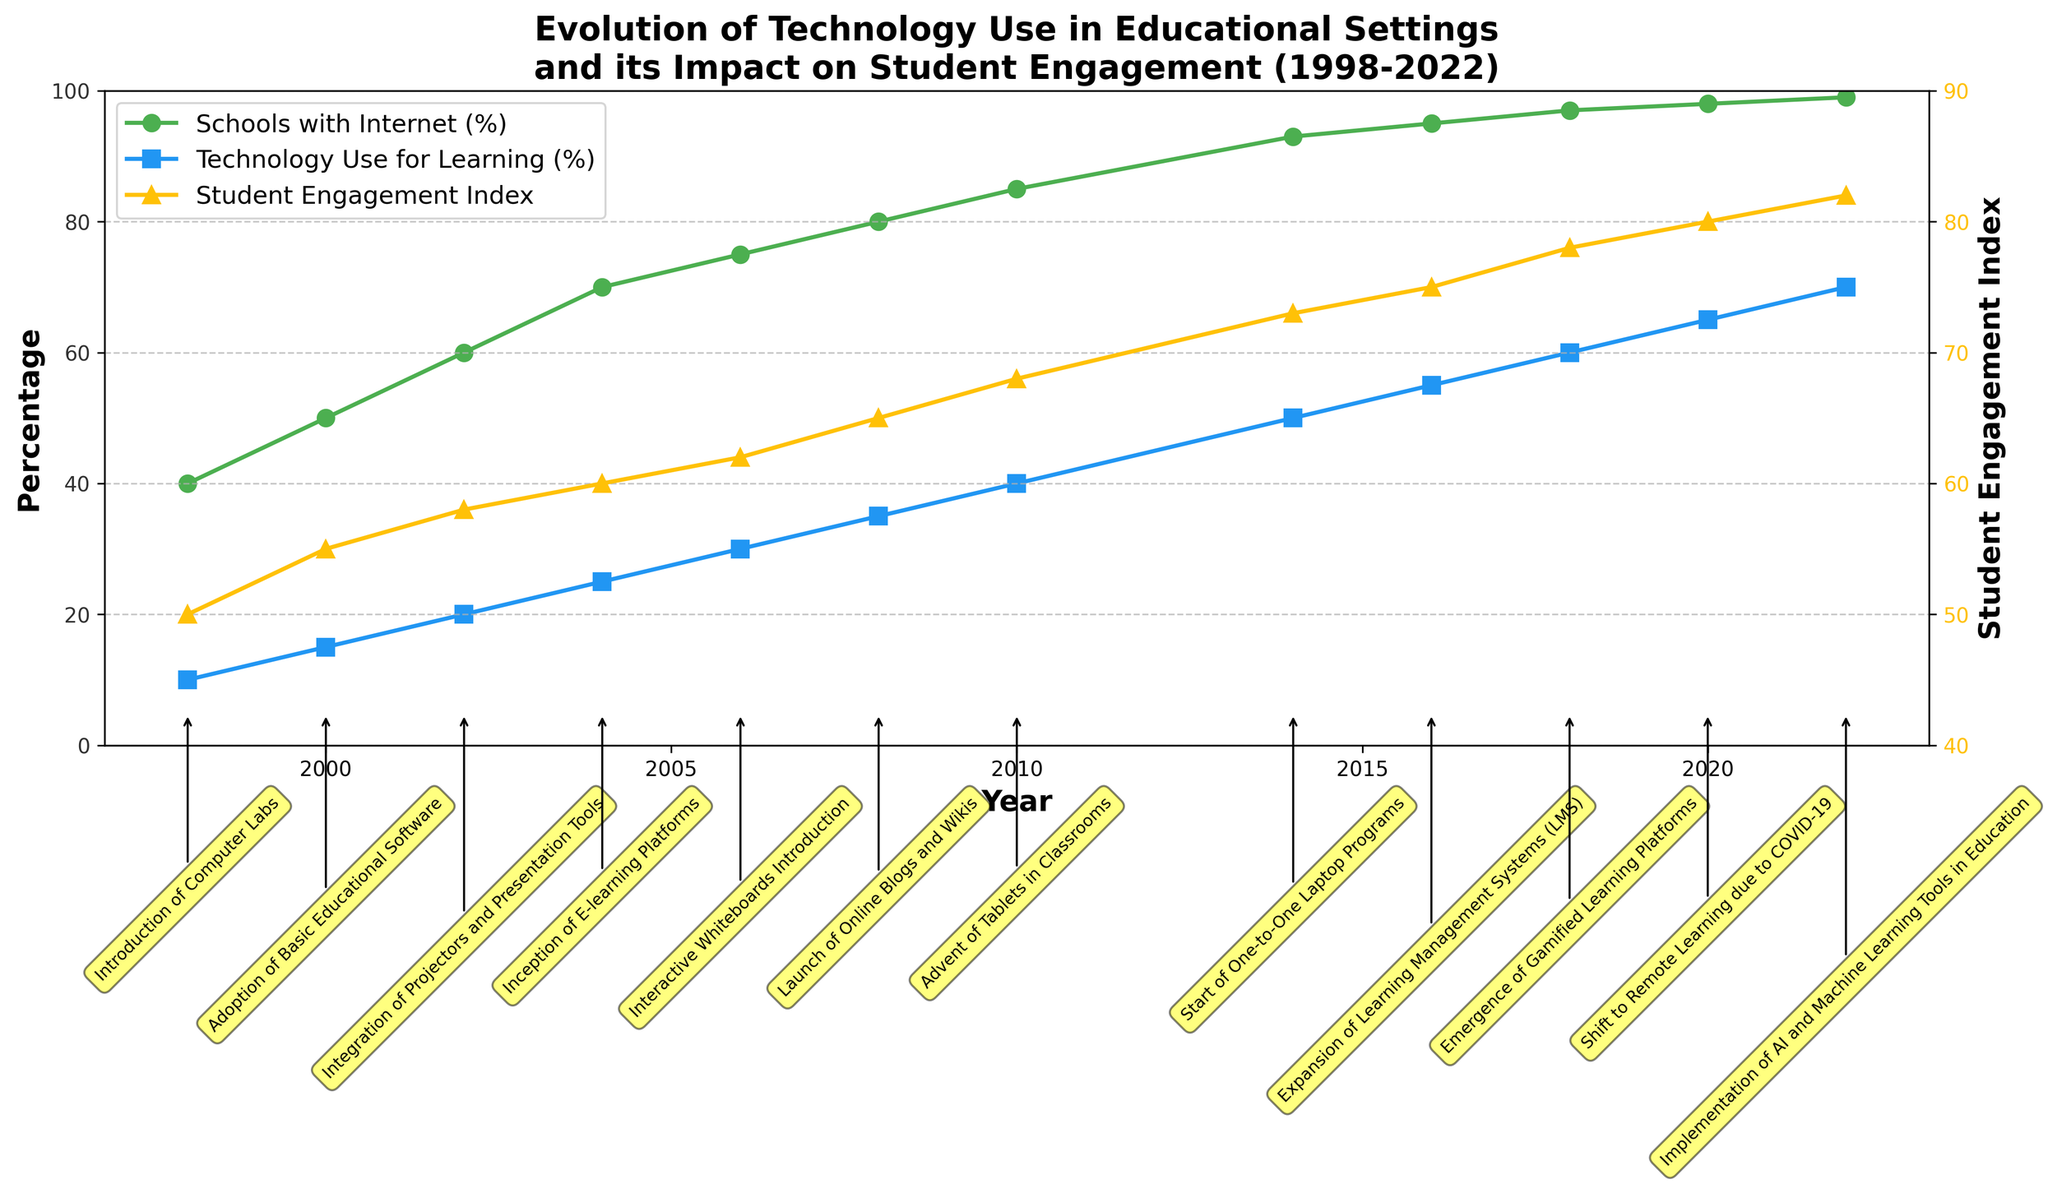What is the title of the plot? The title of the plot is located at the top and provides a summary of what the figure represents.
Answer: Evolution of Technology Use in Educational Settings and its Impact on Student Engagement (1998-2022) What two metrics are plotted on the primary y-axis? The primary y-axis on the left side of the plot typically has labels and descriptions for the metrics it represents.
Answer: Percentage Of Schools With Internet and Technology Use For Learning How many data points are there for the Student Engagement Index? To find the number of data points for the Student Engagement Index, count the number of points or markers plotted for this metric.
Answer: 12 In which year was the "Advent of Tablets in Classrooms"? Look for the annotation text near each data point. The year for the "Advent of Tablets in Classrooms" can be identified next to its corresponding annotation.
Answer: 2010 By how much did the Student Engagement Index increase from 2006 to 2020? Identify the values of the Student Engagement Index in the years 2006 and 2020, then subtract the 2006 value from the 2020 value to find the increase.
Answer: 18 Which metric has the highest value in 2022 and what is that value? Look at the data points for 2022 and compare the values of all metrics. The highest value will be the one that stands out the most.
Answer: Percentage Of Schools With Internet, 99 What was the first major technological innovation mentioned, and in which year did it occur? Check the earliest annotation (located near the left side of the plot) to identify the first technological innovation and its corresponding year.
Answer: Introduction of Computer Labs, 1998 How many distinct major technological innovations are annotated in the plot? Count all the unique annotations present in the plot. Each annotation represents a distinct major technological innovation.
Answer: 12 What year saw the largest increase in Technology Use for Learning compared to the previous year? Examine the slope differences year-over-year for Technology Use For Learning. The steepest positive slope indicates the largest increase.
Answer: 2010 Which innovation is associated with an increase in Student Engagement Index to 75? Trace back from the Student Engagement Index value of 75 to the corresponding year and check the annotation.
Answer: Expansion of Learning Management Systems (LMS) in 2016 